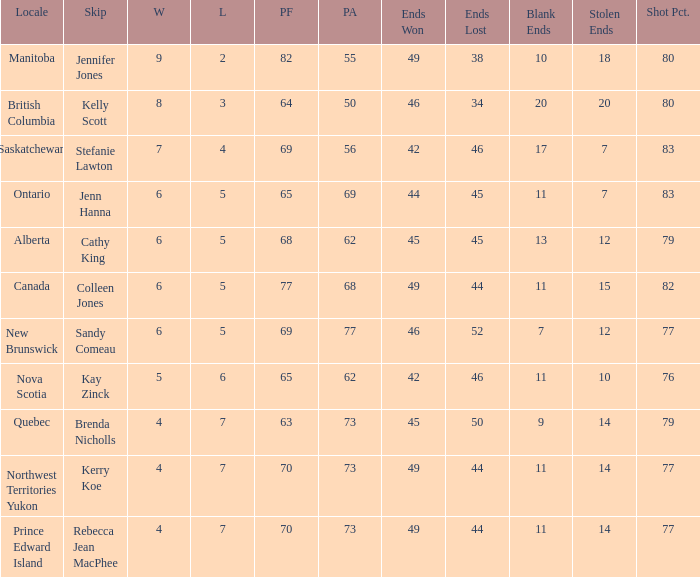I'm looking to parse the entire table for insights. Could you assist me with that? {'header': ['Locale', 'Skip', 'W', 'L', 'PF', 'PA', 'Ends Won', 'Ends Lost', 'Blank Ends', 'Stolen Ends', 'Shot Pct.'], 'rows': [['Manitoba', 'Jennifer Jones', '9', '2', '82', '55', '49', '38', '10', '18', '80'], ['British Columbia', 'Kelly Scott', '8', '3', '64', '50', '46', '34', '20', '20', '80'], ['Saskatchewan', 'Stefanie Lawton', '7', '4', '69', '56', '42', '46', '17', '7', '83'], ['Ontario', 'Jenn Hanna', '6', '5', '65', '69', '44', '45', '11', '7', '83'], ['Alberta', 'Cathy King', '6', '5', '68', '62', '45', '45', '13', '12', '79'], ['Canada', 'Colleen Jones', '6', '5', '77', '68', '49', '44', '11', '15', '82'], ['New Brunswick', 'Sandy Comeau', '6', '5', '69', '77', '46', '52', '7', '12', '77'], ['Nova Scotia', 'Kay Zinck', '5', '6', '65', '62', '42', '46', '11', '10', '76'], ['Quebec', 'Brenda Nicholls', '4', '7', '63', '73', '45', '50', '9', '14', '79'], ['Northwest Territories Yukon', 'Kerry Koe', '4', '7', '70', '73', '49', '44', '11', '14', '77'], ['Prince Edward Island', 'Rebecca Jean MacPhee', '4', '7', '70', '73', '49', '44', '11', '14', '77']]} What is the pa when the bypass is colleen jones? 68.0. 